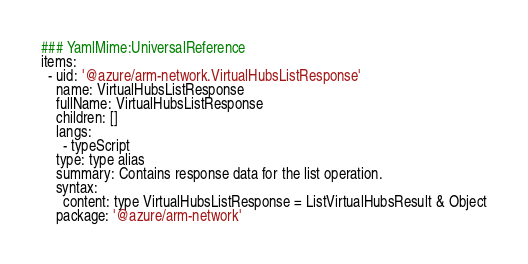Convert code to text. <code><loc_0><loc_0><loc_500><loc_500><_YAML_>### YamlMime:UniversalReference
items:
  - uid: '@azure/arm-network.VirtualHubsListResponse'
    name: VirtualHubsListResponse
    fullName: VirtualHubsListResponse
    children: []
    langs:
      - typeScript
    type: type alias
    summary: Contains response data for the list operation.
    syntax:
      content: type VirtualHubsListResponse = ListVirtualHubsResult & Object
    package: '@azure/arm-network'
</code> 